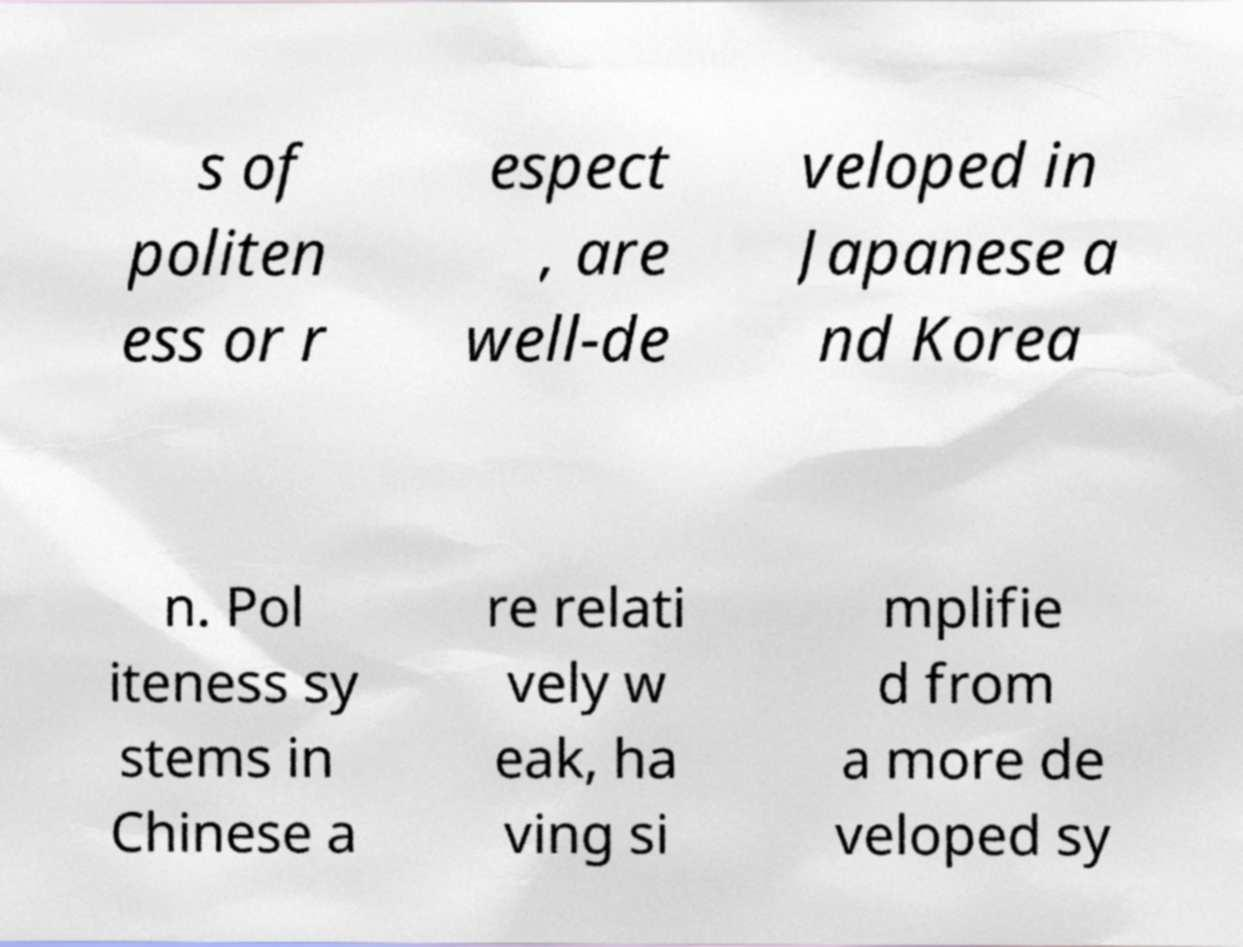Could you assist in decoding the text presented in this image and type it out clearly? s of politen ess or r espect , are well-de veloped in Japanese a nd Korea n. Pol iteness sy stems in Chinese a re relati vely w eak, ha ving si mplifie d from a more de veloped sy 